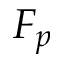Convert formula to latex. <formula><loc_0><loc_0><loc_500><loc_500>F _ { p }</formula> 